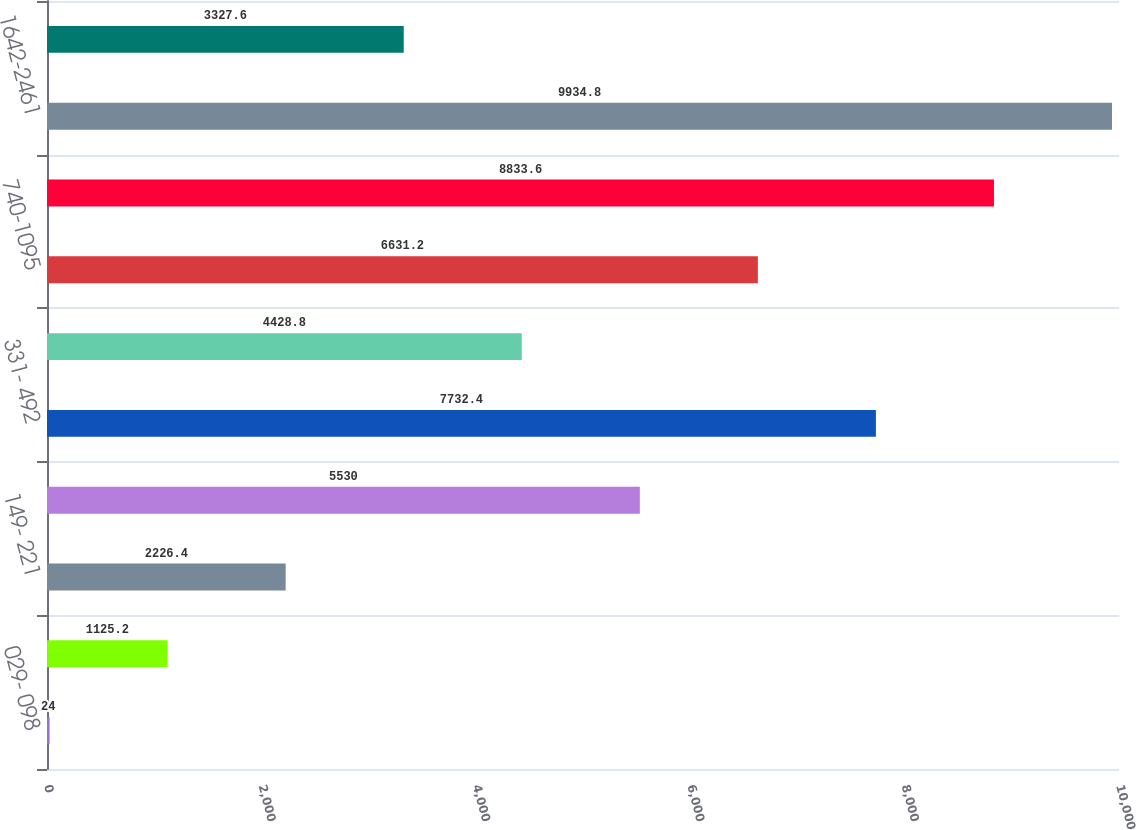Convert chart. <chart><loc_0><loc_0><loc_500><loc_500><bar_chart><fcel>029- 098<fcel>101- 147<fcel>149- 221<fcel>231- 330<fcel>331- 492<fcel>496- 733<fcel>740-1095<fcel>1104-1641<fcel>1642-2461<fcel>2465-3526<nl><fcel>24<fcel>1125.2<fcel>2226.4<fcel>5530<fcel>7732.4<fcel>4428.8<fcel>6631.2<fcel>8833.6<fcel>9934.8<fcel>3327.6<nl></chart> 